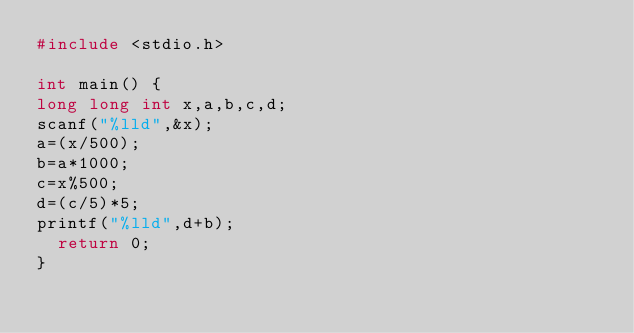<code> <loc_0><loc_0><loc_500><loc_500><_C_>#include <stdio.h>

int main() {
long long int x,a,b,c,d;
scanf("%lld",&x);
a=(x/500);
b=a*1000;
c=x%500;
d=(c/5)*5;
printf("%lld",d+b);
	return 0;
}</code> 